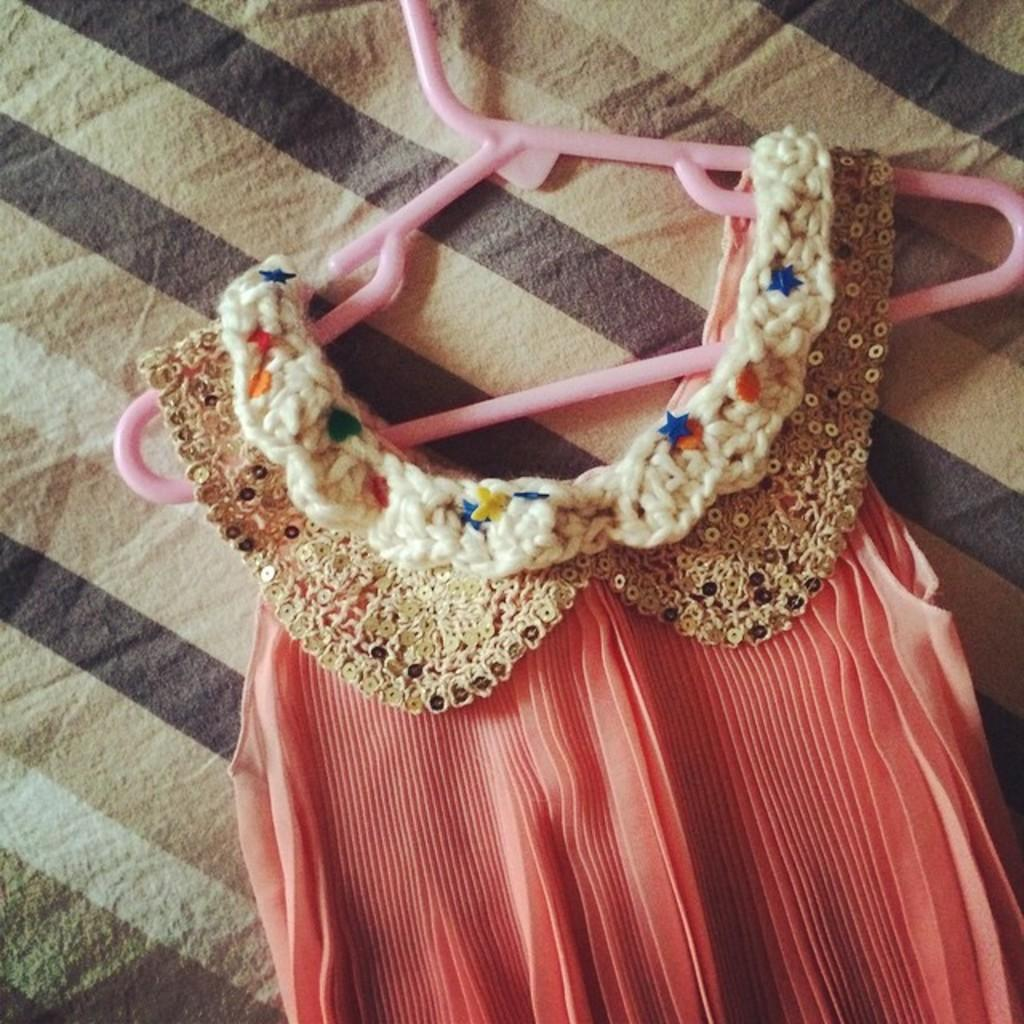What is hanging on an object in the image? There is a dress on a hanger in the image. Can you describe the surface on which the hanger is placed? The hanger is placed on a cloth in the image. Is the dress being worn by a person sitting on a throne in the image? There is no throne or person wearing the dress in the image; it is simply a dress on a hanger placed on a cloth. Can you tell me how the dress helps the person avoid quicksand in the image? There is no quicksand or person wearing the dress in the image; it is just a dress on a hanger placed on a cloth. 